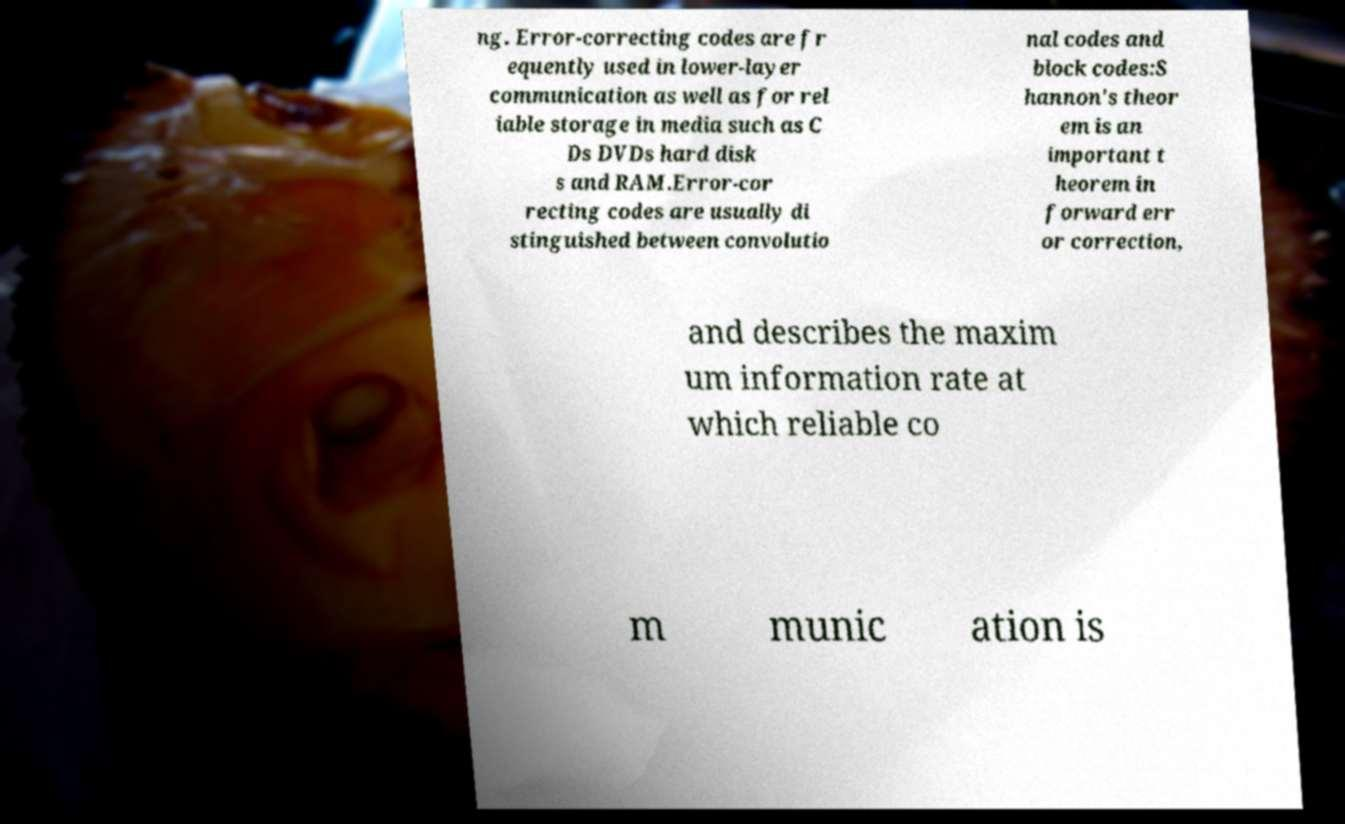Can you accurately transcribe the text from the provided image for me? ng. Error-correcting codes are fr equently used in lower-layer communication as well as for rel iable storage in media such as C Ds DVDs hard disk s and RAM.Error-cor recting codes are usually di stinguished between convolutio nal codes and block codes:S hannon's theor em is an important t heorem in forward err or correction, and describes the maxim um information rate at which reliable co m munic ation is 